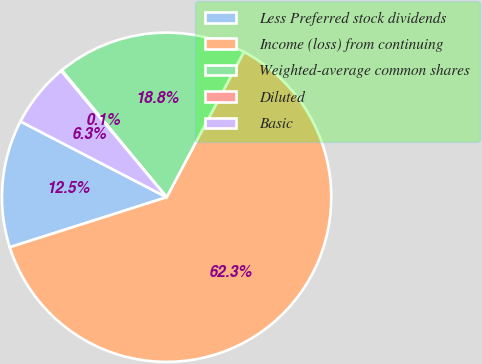<chart> <loc_0><loc_0><loc_500><loc_500><pie_chart><fcel>Less Preferred stock dividends<fcel>Income (loss) from continuing<fcel>Weighted-average common shares<fcel>Diluted<fcel>Basic<nl><fcel>12.53%<fcel>62.31%<fcel>18.76%<fcel>0.09%<fcel>6.31%<nl></chart> 